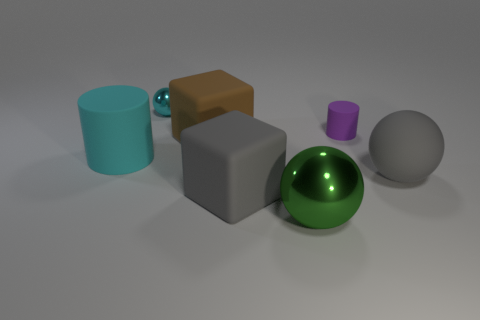There is a cylinder that is behind the large brown matte block that is in front of the tiny cylinder; what color is it?
Ensure brevity in your answer.  Purple. There is a shiny sphere that is the same size as the purple rubber object; what color is it?
Give a very brief answer. Cyan. What number of rubber things are large gray spheres or tiny cyan cylinders?
Give a very brief answer. 1. There is a gray rubber thing in front of the gray matte ball; what number of gray things are behind it?
Keep it short and to the point. 1. The block that is the same color as the rubber ball is what size?
Provide a succinct answer. Large. What number of things are gray spheres or things to the left of the purple rubber object?
Your answer should be very brief. 6. Is there a cyan cylinder made of the same material as the large brown thing?
Make the answer very short. Yes. How many things are in front of the small purple matte cylinder and on the left side of the tiny purple rubber object?
Your answer should be compact. 4. What material is the small thing that is on the left side of the large green shiny thing?
Your answer should be compact. Metal. There is a gray block that is the same material as the brown cube; what is its size?
Offer a terse response. Large. 